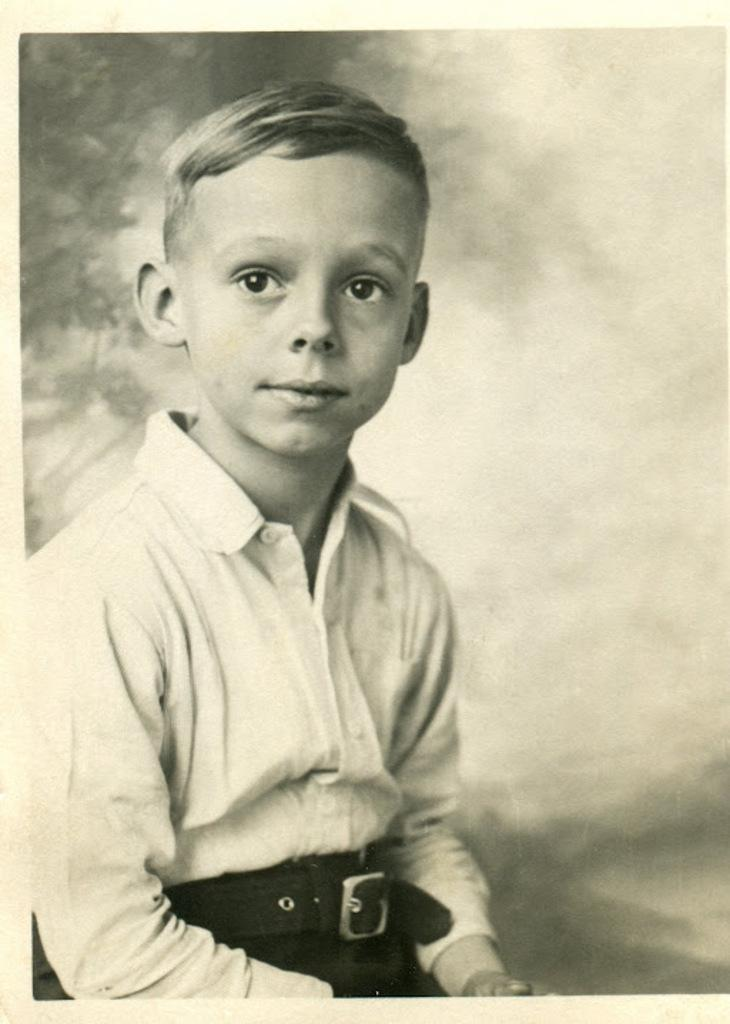What is the color scheme of the picture? The picture is black and white. Can you describe the main subject in the image? There is a boy in the picture. Where is the boy positioned in the image? The boy is sitting on the left side. What type of celery is the boy holding in the picture? There is no celery present in the picture; it is a black and white image of a boy sitting on the left side. 